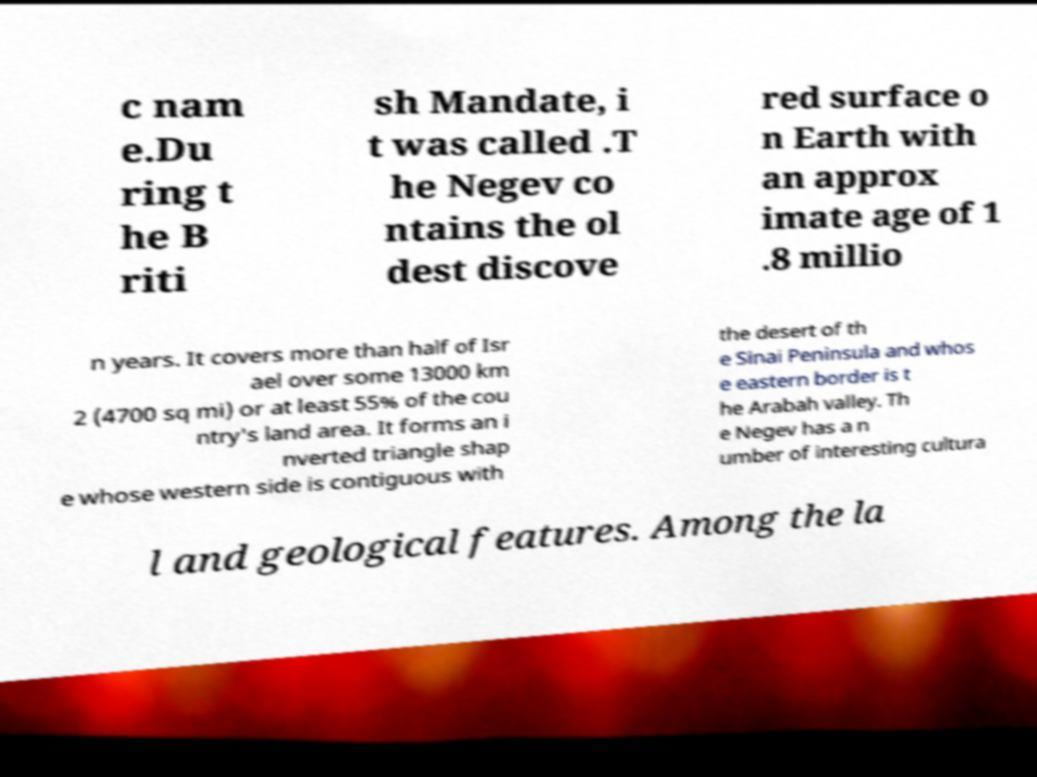Can you accurately transcribe the text from the provided image for me? c nam e.Du ring t he B riti sh Mandate, i t was called .T he Negev co ntains the ol dest discove red surface o n Earth with an approx imate age of 1 .8 millio n years. It covers more than half of Isr ael over some 13000 km 2 (4700 sq mi) or at least 55% of the cou ntry's land area. It forms an i nverted triangle shap e whose western side is contiguous with the desert of th e Sinai Peninsula and whos e eastern border is t he Arabah valley. Th e Negev has a n umber of interesting cultura l and geological features. Among the la 